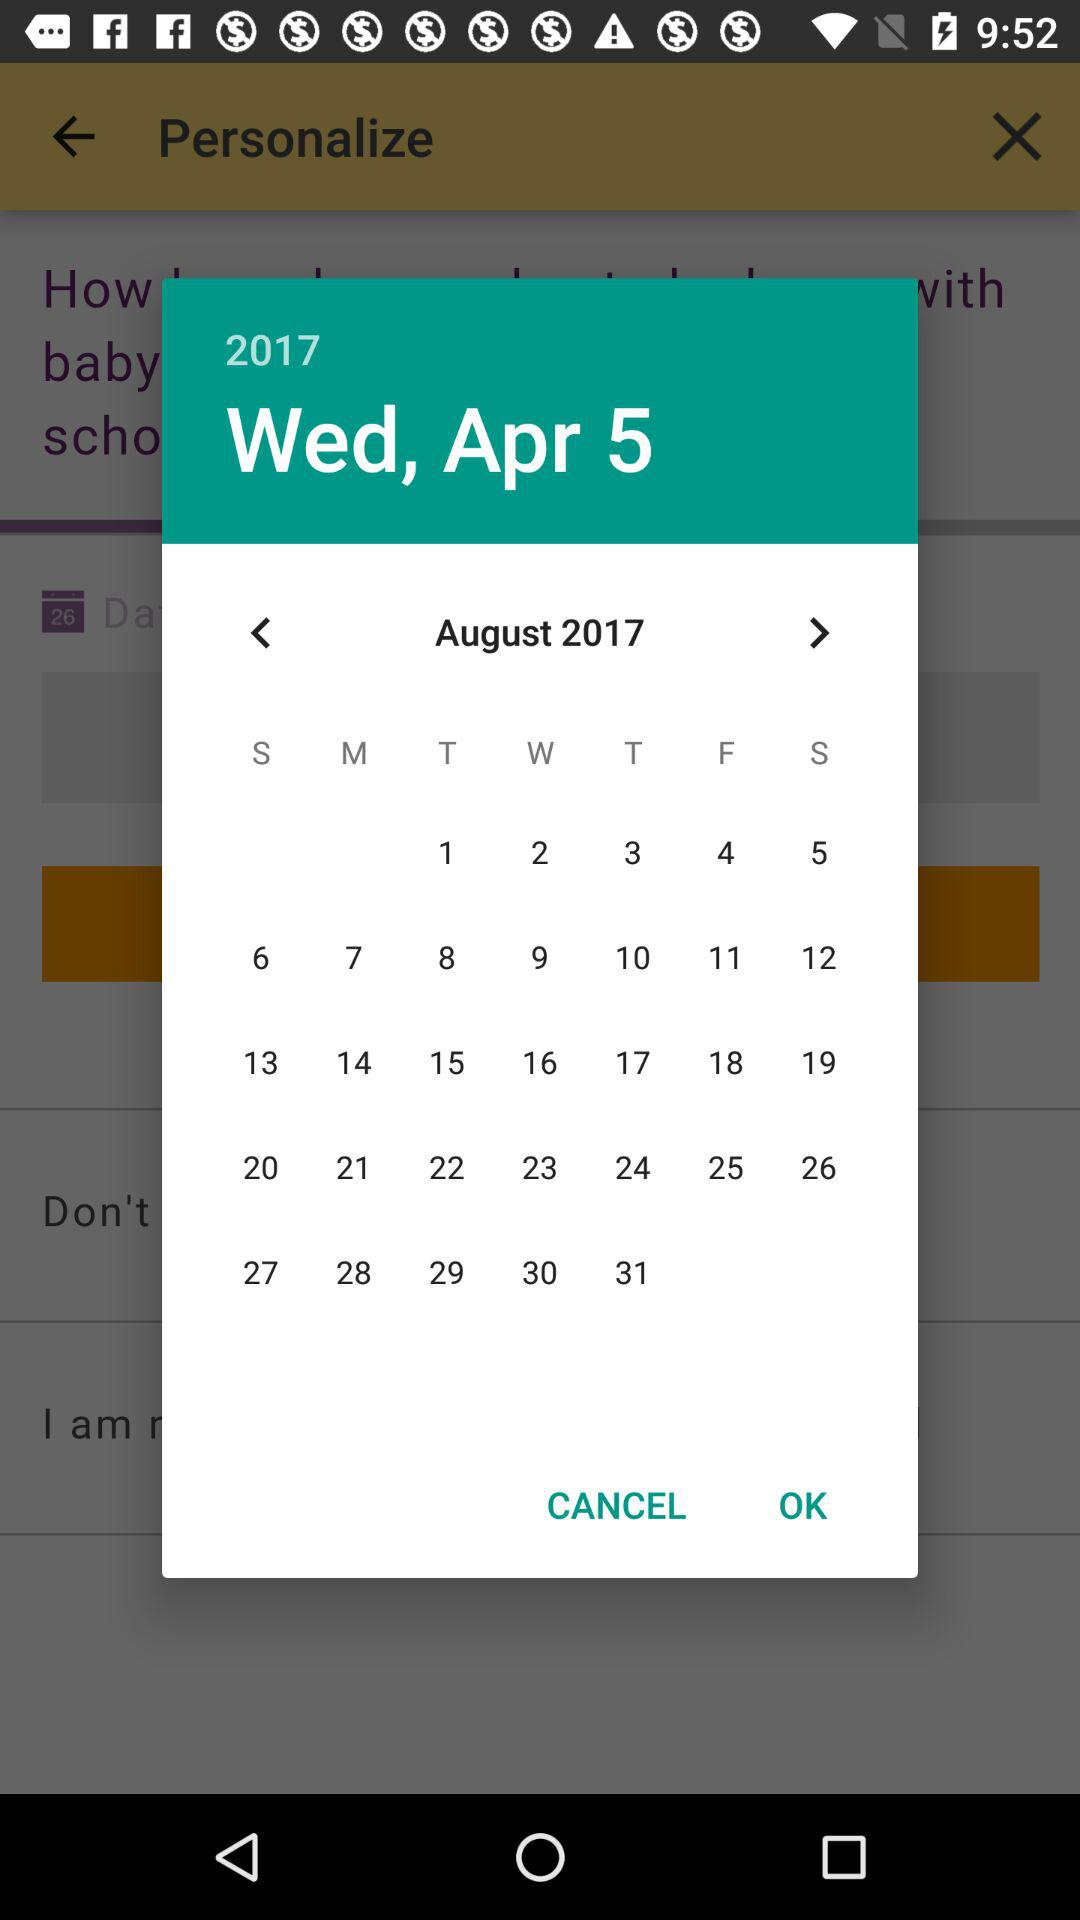What is the selected year? The selected year is 2017. 